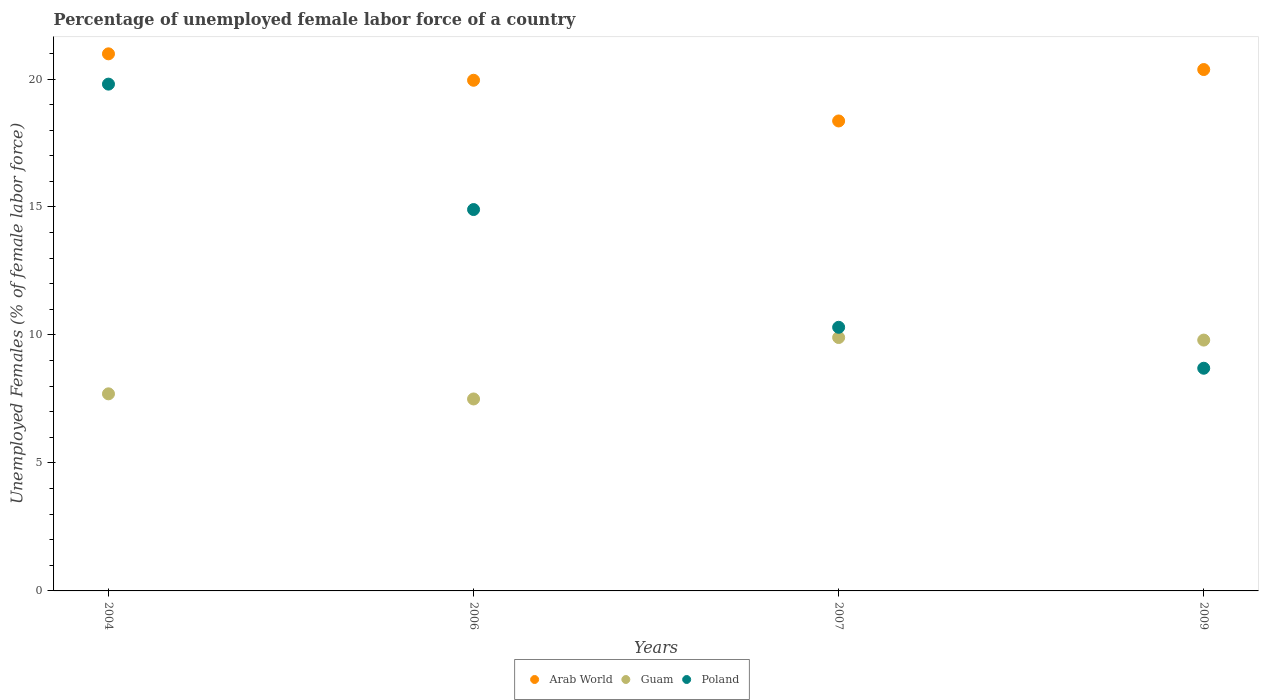What is the percentage of unemployed female labor force in Arab World in 2009?
Keep it short and to the point. 20.37. Across all years, what is the maximum percentage of unemployed female labor force in Arab World?
Offer a very short reply. 20.98. Across all years, what is the minimum percentage of unemployed female labor force in Poland?
Keep it short and to the point. 8.7. In which year was the percentage of unemployed female labor force in Poland maximum?
Make the answer very short. 2004. What is the total percentage of unemployed female labor force in Guam in the graph?
Your response must be concise. 34.9. What is the difference between the percentage of unemployed female labor force in Guam in 2006 and that in 2009?
Provide a short and direct response. -2.3. What is the difference between the percentage of unemployed female labor force in Arab World in 2004 and the percentage of unemployed female labor force in Guam in 2009?
Make the answer very short. 11.18. What is the average percentage of unemployed female labor force in Guam per year?
Keep it short and to the point. 8.72. In the year 2006, what is the difference between the percentage of unemployed female labor force in Guam and percentage of unemployed female labor force in Arab World?
Offer a very short reply. -12.45. What is the ratio of the percentage of unemployed female labor force in Poland in 2004 to that in 2007?
Offer a terse response. 1.92. Is the percentage of unemployed female labor force in Arab World in 2006 less than that in 2007?
Provide a short and direct response. No. What is the difference between the highest and the second highest percentage of unemployed female labor force in Guam?
Keep it short and to the point. 0.1. What is the difference between the highest and the lowest percentage of unemployed female labor force in Poland?
Your response must be concise. 11.1. Is the percentage of unemployed female labor force in Guam strictly greater than the percentage of unemployed female labor force in Poland over the years?
Keep it short and to the point. No. Is the percentage of unemployed female labor force in Guam strictly less than the percentage of unemployed female labor force in Poland over the years?
Your answer should be compact. No. How many dotlines are there?
Keep it short and to the point. 3. Are the values on the major ticks of Y-axis written in scientific E-notation?
Your answer should be very brief. No. Does the graph contain grids?
Keep it short and to the point. No. How many legend labels are there?
Keep it short and to the point. 3. What is the title of the graph?
Offer a terse response. Percentage of unemployed female labor force of a country. Does "Italy" appear as one of the legend labels in the graph?
Provide a succinct answer. No. What is the label or title of the X-axis?
Provide a succinct answer. Years. What is the label or title of the Y-axis?
Keep it short and to the point. Unemployed Females (% of female labor force). What is the Unemployed Females (% of female labor force) of Arab World in 2004?
Offer a very short reply. 20.98. What is the Unemployed Females (% of female labor force) in Guam in 2004?
Give a very brief answer. 7.7. What is the Unemployed Females (% of female labor force) of Poland in 2004?
Your response must be concise. 19.8. What is the Unemployed Females (% of female labor force) in Arab World in 2006?
Provide a short and direct response. 19.95. What is the Unemployed Females (% of female labor force) of Guam in 2006?
Your answer should be very brief. 7.5. What is the Unemployed Females (% of female labor force) in Poland in 2006?
Your answer should be compact. 14.9. What is the Unemployed Females (% of female labor force) in Arab World in 2007?
Offer a very short reply. 18.36. What is the Unemployed Females (% of female labor force) of Guam in 2007?
Make the answer very short. 9.9. What is the Unemployed Females (% of female labor force) in Poland in 2007?
Provide a succinct answer. 10.3. What is the Unemployed Females (% of female labor force) of Arab World in 2009?
Offer a very short reply. 20.37. What is the Unemployed Females (% of female labor force) in Guam in 2009?
Your answer should be compact. 9.8. What is the Unemployed Females (% of female labor force) in Poland in 2009?
Offer a very short reply. 8.7. Across all years, what is the maximum Unemployed Females (% of female labor force) of Arab World?
Your answer should be compact. 20.98. Across all years, what is the maximum Unemployed Females (% of female labor force) of Guam?
Keep it short and to the point. 9.9. Across all years, what is the maximum Unemployed Females (% of female labor force) of Poland?
Offer a terse response. 19.8. Across all years, what is the minimum Unemployed Females (% of female labor force) in Arab World?
Keep it short and to the point. 18.36. Across all years, what is the minimum Unemployed Females (% of female labor force) in Poland?
Offer a terse response. 8.7. What is the total Unemployed Females (% of female labor force) of Arab World in the graph?
Ensure brevity in your answer.  79.67. What is the total Unemployed Females (% of female labor force) of Guam in the graph?
Offer a terse response. 34.9. What is the total Unemployed Females (% of female labor force) of Poland in the graph?
Your response must be concise. 53.7. What is the difference between the Unemployed Females (% of female labor force) of Arab World in 2004 and that in 2006?
Give a very brief answer. 1.03. What is the difference between the Unemployed Females (% of female labor force) of Poland in 2004 and that in 2006?
Your response must be concise. 4.9. What is the difference between the Unemployed Females (% of female labor force) of Arab World in 2004 and that in 2007?
Ensure brevity in your answer.  2.62. What is the difference between the Unemployed Females (% of female labor force) of Poland in 2004 and that in 2007?
Your answer should be very brief. 9.5. What is the difference between the Unemployed Females (% of female labor force) of Arab World in 2004 and that in 2009?
Provide a succinct answer. 0.61. What is the difference between the Unemployed Females (% of female labor force) in Poland in 2004 and that in 2009?
Offer a terse response. 11.1. What is the difference between the Unemployed Females (% of female labor force) in Arab World in 2006 and that in 2007?
Your answer should be very brief. 1.59. What is the difference between the Unemployed Females (% of female labor force) in Arab World in 2006 and that in 2009?
Keep it short and to the point. -0.42. What is the difference between the Unemployed Females (% of female labor force) in Guam in 2006 and that in 2009?
Your answer should be very brief. -2.3. What is the difference between the Unemployed Females (% of female labor force) of Arab World in 2007 and that in 2009?
Offer a terse response. -2.01. What is the difference between the Unemployed Females (% of female labor force) in Poland in 2007 and that in 2009?
Provide a succinct answer. 1.6. What is the difference between the Unemployed Females (% of female labor force) of Arab World in 2004 and the Unemployed Females (% of female labor force) of Guam in 2006?
Offer a very short reply. 13.48. What is the difference between the Unemployed Females (% of female labor force) of Arab World in 2004 and the Unemployed Females (% of female labor force) of Poland in 2006?
Give a very brief answer. 6.08. What is the difference between the Unemployed Females (% of female labor force) of Guam in 2004 and the Unemployed Females (% of female labor force) of Poland in 2006?
Keep it short and to the point. -7.2. What is the difference between the Unemployed Females (% of female labor force) of Arab World in 2004 and the Unemployed Females (% of female labor force) of Guam in 2007?
Give a very brief answer. 11.08. What is the difference between the Unemployed Females (% of female labor force) of Arab World in 2004 and the Unemployed Females (% of female labor force) of Poland in 2007?
Your response must be concise. 10.68. What is the difference between the Unemployed Females (% of female labor force) of Arab World in 2004 and the Unemployed Females (% of female labor force) of Guam in 2009?
Give a very brief answer. 11.18. What is the difference between the Unemployed Females (% of female labor force) in Arab World in 2004 and the Unemployed Females (% of female labor force) in Poland in 2009?
Make the answer very short. 12.28. What is the difference between the Unemployed Females (% of female labor force) in Arab World in 2006 and the Unemployed Females (% of female labor force) in Guam in 2007?
Offer a very short reply. 10.05. What is the difference between the Unemployed Females (% of female labor force) in Arab World in 2006 and the Unemployed Females (% of female labor force) in Poland in 2007?
Your answer should be very brief. 9.65. What is the difference between the Unemployed Females (% of female labor force) of Guam in 2006 and the Unemployed Females (% of female labor force) of Poland in 2007?
Provide a short and direct response. -2.8. What is the difference between the Unemployed Females (% of female labor force) of Arab World in 2006 and the Unemployed Females (% of female labor force) of Guam in 2009?
Keep it short and to the point. 10.15. What is the difference between the Unemployed Females (% of female labor force) of Arab World in 2006 and the Unemployed Females (% of female labor force) of Poland in 2009?
Your answer should be compact. 11.25. What is the difference between the Unemployed Females (% of female labor force) in Arab World in 2007 and the Unemployed Females (% of female labor force) in Guam in 2009?
Give a very brief answer. 8.56. What is the difference between the Unemployed Females (% of female labor force) in Arab World in 2007 and the Unemployed Females (% of female labor force) in Poland in 2009?
Provide a succinct answer. 9.66. What is the difference between the Unemployed Females (% of female labor force) in Guam in 2007 and the Unemployed Females (% of female labor force) in Poland in 2009?
Keep it short and to the point. 1.2. What is the average Unemployed Females (% of female labor force) in Arab World per year?
Provide a short and direct response. 19.92. What is the average Unemployed Females (% of female labor force) of Guam per year?
Your response must be concise. 8.72. What is the average Unemployed Females (% of female labor force) of Poland per year?
Ensure brevity in your answer.  13.43. In the year 2004, what is the difference between the Unemployed Females (% of female labor force) of Arab World and Unemployed Females (% of female labor force) of Guam?
Offer a terse response. 13.28. In the year 2004, what is the difference between the Unemployed Females (% of female labor force) of Arab World and Unemployed Females (% of female labor force) of Poland?
Offer a terse response. 1.18. In the year 2004, what is the difference between the Unemployed Females (% of female labor force) of Guam and Unemployed Females (% of female labor force) of Poland?
Your answer should be very brief. -12.1. In the year 2006, what is the difference between the Unemployed Females (% of female labor force) in Arab World and Unemployed Females (% of female labor force) in Guam?
Make the answer very short. 12.45. In the year 2006, what is the difference between the Unemployed Females (% of female labor force) of Arab World and Unemployed Females (% of female labor force) of Poland?
Offer a terse response. 5.05. In the year 2006, what is the difference between the Unemployed Females (% of female labor force) in Guam and Unemployed Females (% of female labor force) in Poland?
Provide a short and direct response. -7.4. In the year 2007, what is the difference between the Unemployed Females (% of female labor force) of Arab World and Unemployed Females (% of female labor force) of Guam?
Keep it short and to the point. 8.46. In the year 2007, what is the difference between the Unemployed Females (% of female labor force) of Arab World and Unemployed Females (% of female labor force) of Poland?
Make the answer very short. 8.06. In the year 2009, what is the difference between the Unemployed Females (% of female labor force) of Arab World and Unemployed Females (% of female labor force) of Guam?
Your answer should be compact. 10.57. In the year 2009, what is the difference between the Unemployed Females (% of female labor force) of Arab World and Unemployed Females (% of female labor force) of Poland?
Your response must be concise. 11.67. What is the ratio of the Unemployed Females (% of female labor force) of Arab World in 2004 to that in 2006?
Offer a very short reply. 1.05. What is the ratio of the Unemployed Females (% of female labor force) in Guam in 2004 to that in 2006?
Your response must be concise. 1.03. What is the ratio of the Unemployed Females (% of female labor force) of Poland in 2004 to that in 2006?
Ensure brevity in your answer.  1.33. What is the ratio of the Unemployed Females (% of female labor force) of Arab World in 2004 to that in 2007?
Your answer should be very brief. 1.14. What is the ratio of the Unemployed Females (% of female labor force) of Guam in 2004 to that in 2007?
Offer a terse response. 0.78. What is the ratio of the Unemployed Females (% of female labor force) in Poland in 2004 to that in 2007?
Your answer should be compact. 1.92. What is the ratio of the Unemployed Females (% of female labor force) in Arab World in 2004 to that in 2009?
Your response must be concise. 1.03. What is the ratio of the Unemployed Females (% of female labor force) in Guam in 2004 to that in 2009?
Provide a short and direct response. 0.79. What is the ratio of the Unemployed Females (% of female labor force) in Poland in 2004 to that in 2009?
Provide a succinct answer. 2.28. What is the ratio of the Unemployed Females (% of female labor force) of Arab World in 2006 to that in 2007?
Your response must be concise. 1.09. What is the ratio of the Unemployed Females (% of female labor force) of Guam in 2006 to that in 2007?
Offer a very short reply. 0.76. What is the ratio of the Unemployed Females (% of female labor force) in Poland in 2006 to that in 2007?
Keep it short and to the point. 1.45. What is the ratio of the Unemployed Females (% of female labor force) of Arab World in 2006 to that in 2009?
Offer a very short reply. 0.98. What is the ratio of the Unemployed Females (% of female labor force) in Guam in 2006 to that in 2009?
Provide a short and direct response. 0.77. What is the ratio of the Unemployed Females (% of female labor force) of Poland in 2006 to that in 2009?
Your answer should be very brief. 1.71. What is the ratio of the Unemployed Females (% of female labor force) in Arab World in 2007 to that in 2009?
Ensure brevity in your answer.  0.9. What is the ratio of the Unemployed Females (% of female labor force) of Guam in 2007 to that in 2009?
Your answer should be very brief. 1.01. What is the ratio of the Unemployed Females (% of female labor force) of Poland in 2007 to that in 2009?
Ensure brevity in your answer.  1.18. What is the difference between the highest and the second highest Unemployed Females (% of female labor force) in Arab World?
Give a very brief answer. 0.61. What is the difference between the highest and the second highest Unemployed Females (% of female labor force) in Poland?
Ensure brevity in your answer.  4.9. What is the difference between the highest and the lowest Unemployed Females (% of female labor force) in Arab World?
Provide a succinct answer. 2.62. What is the difference between the highest and the lowest Unemployed Females (% of female labor force) of Poland?
Provide a short and direct response. 11.1. 